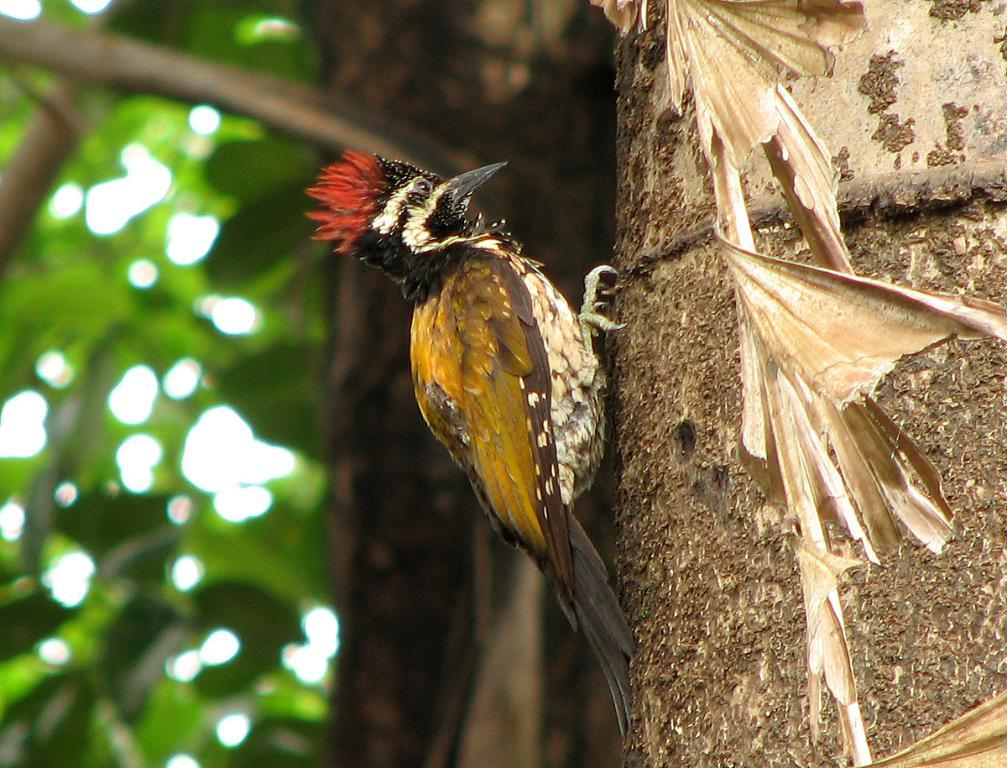What is located on the right side of the image? There is a tree on the right side of the image. What can be seen on the tree? There is a bird on the tree. Can you describe the bird's appearance? The bird has multiple colors. How would you describe the background of the image? The background of the image is blurred. What type of grain is being cut by the scissors in the image? There are no scissors or grain present in the image. How many waves can be seen in the background of the image? There are no waves visible in the background of the image. 